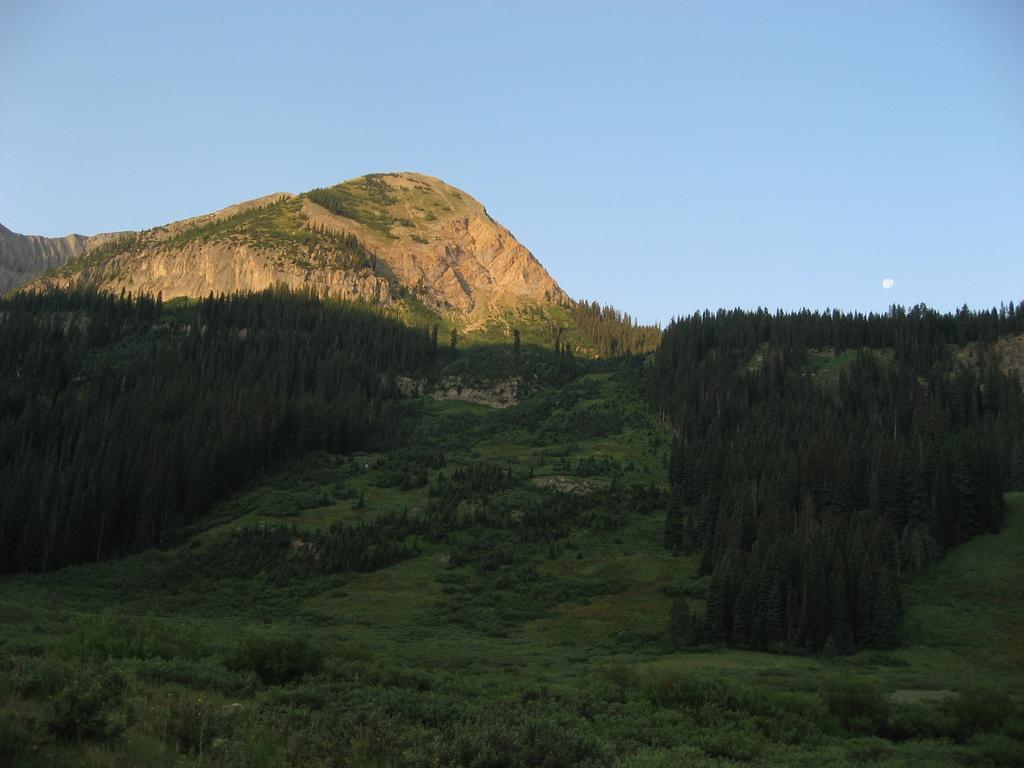Please provide a concise description of this image. In this picture we can see the sky, hills and the thicket. At the bottom portion of the picture we can see the trees, plants and the green grass. 